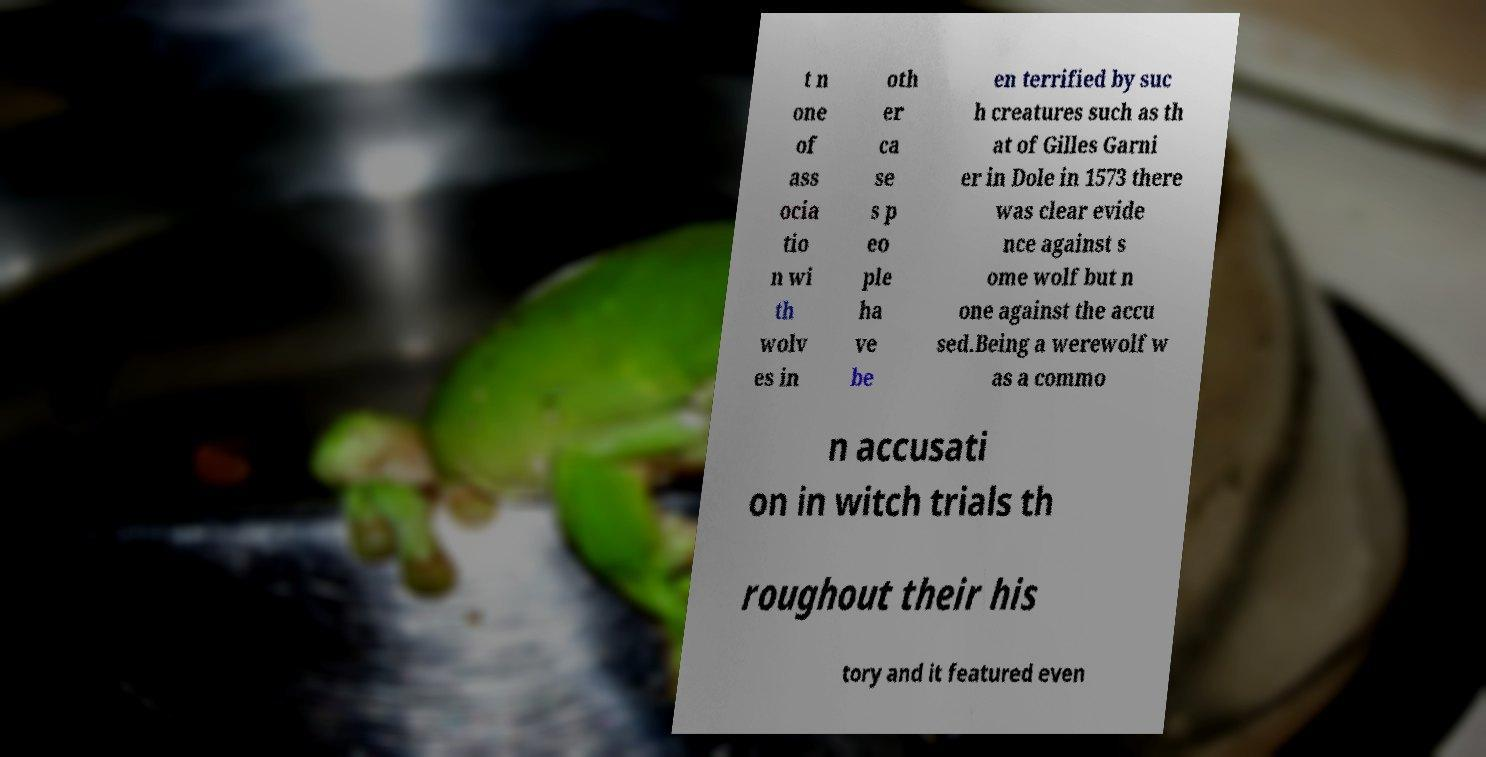What messages or text are displayed in this image? I need them in a readable, typed format. t n one of ass ocia tio n wi th wolv es in oth er ca se s p eo ple ha ve be en terrified by suc h creatures such as th at of Gilles Garni er in Dole in 1573 there was clear evide nce against s ome wolf but n one against the accu sed.Being a werewolf w as a commo n accusati on in witch trials th roughout their his tory and it featured even 